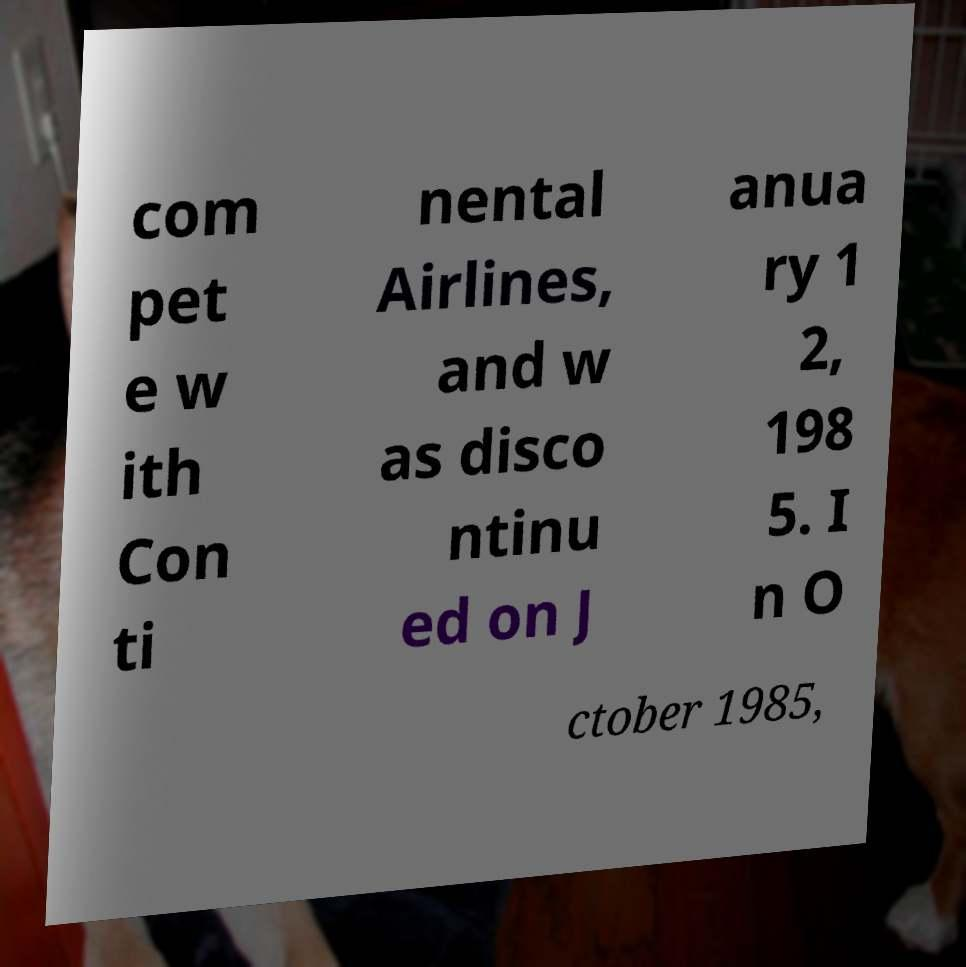For documentation purposes, I need the text within this image transcribed. Could you provide that? com pet e w ith Con ti nental Airlines, and w as disco ntinu ed on J anua ry 1 2, 198 5. I n O ctober 1985, 